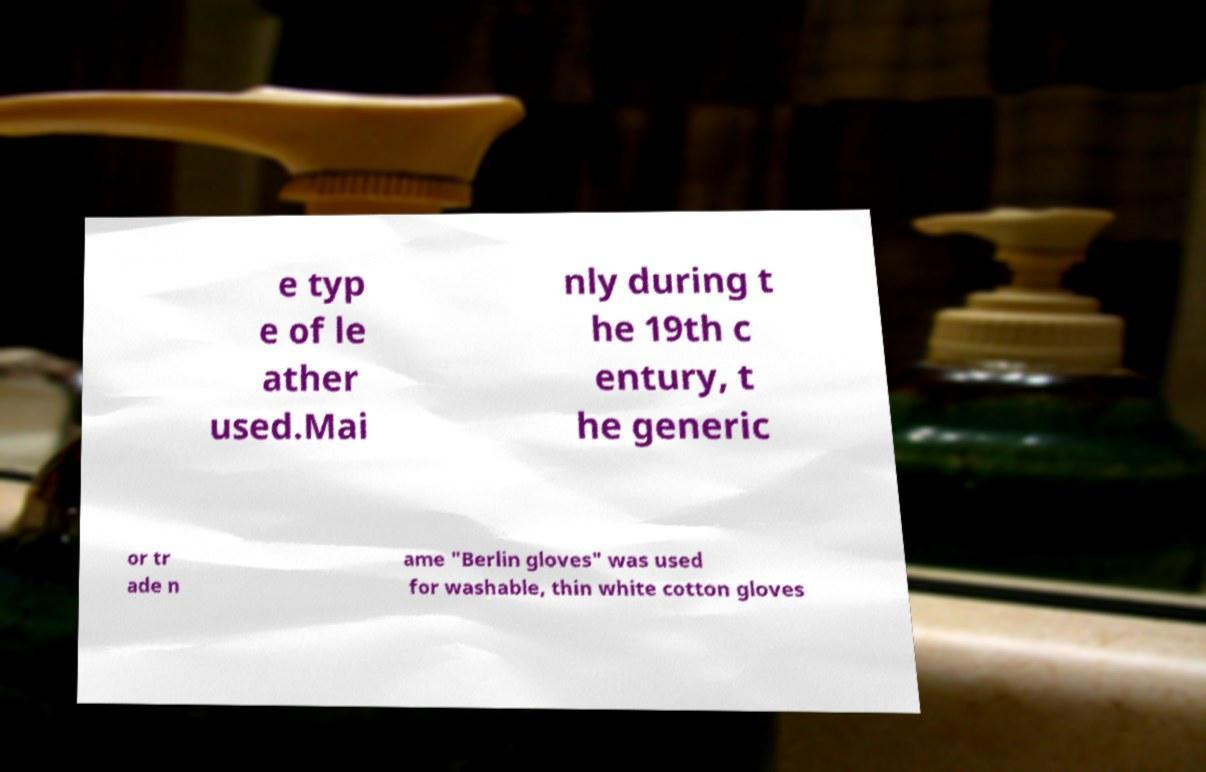Could you extract and type out the text from this image? e typ e of le ather used.Mai nly during t he 19th c entury, t he generic or tr ade n ame "Berlin gloves" was used for washable, thin white cotton gloves 